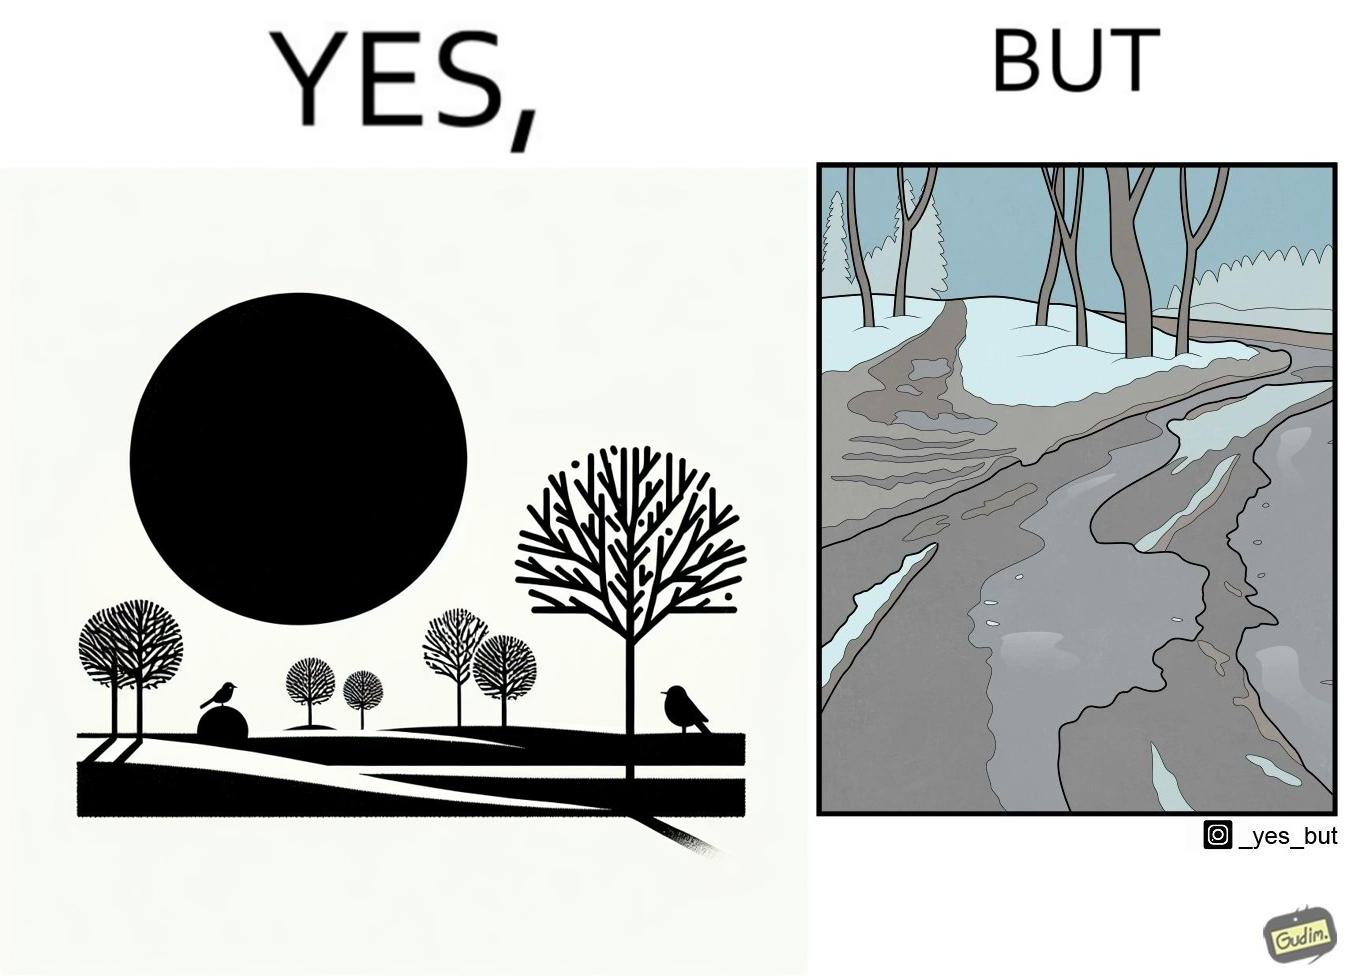Describe the satirical element in this image. The image is funny, as from far, snow covered mountains look really scenic and completely white, but when zooming in near trees, the ground is partially covered in snow, and is not as scenic anymore. 